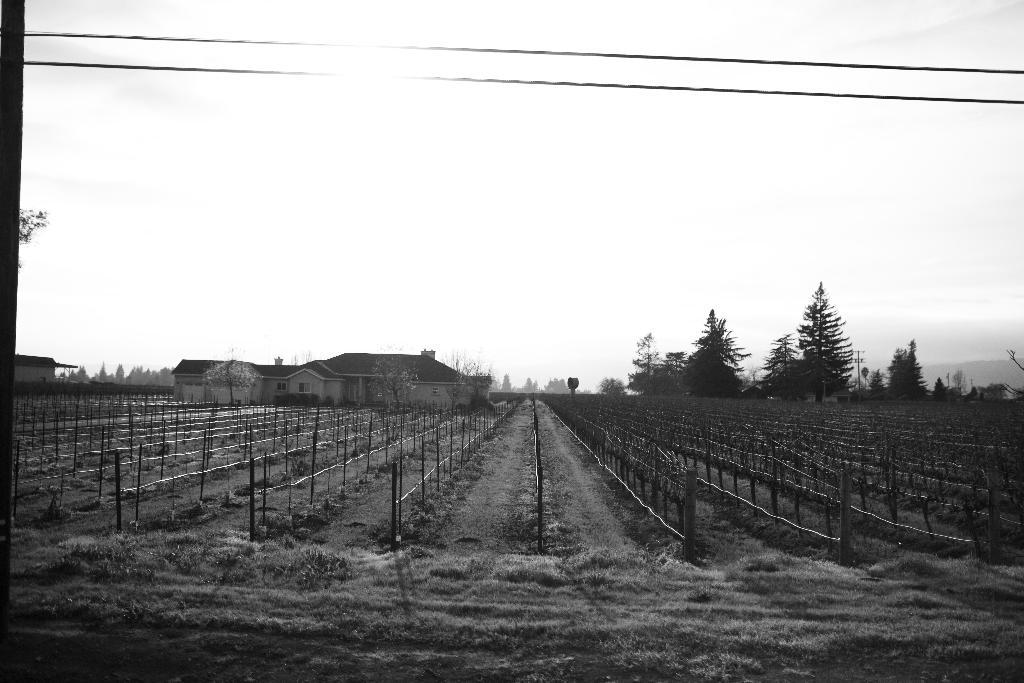What type of vegetation can be seen in the image? There are trees in the image. What type of structures are present in the image? There are houses in the image. What are the poles in the image used for? The poles in the image are likely used for supporting wires or other infrastructure. What are the ropes in the image used for? The ropes in the image may be used for various purposes, such as tying or hanging objects. What can be seen connecting the poles in the image? There are wires connecting the poles in the image. What type of ground surface is visible in the image? There is grass in the image. What is visible in the background of the image? The sky is visible in the image. What is the color scheme of the image? The image is in black and white mode. How much money is being exchanged between the trees in the image? There is no money exchange depicted in the image, as it features trees, houses, poles, ropes, wires, grass, and the sky in black and white mode. Can you describe the bite marks on the wires in the image? There are no bite marks visible on the wires in the image, as they appear to be in good condition. 